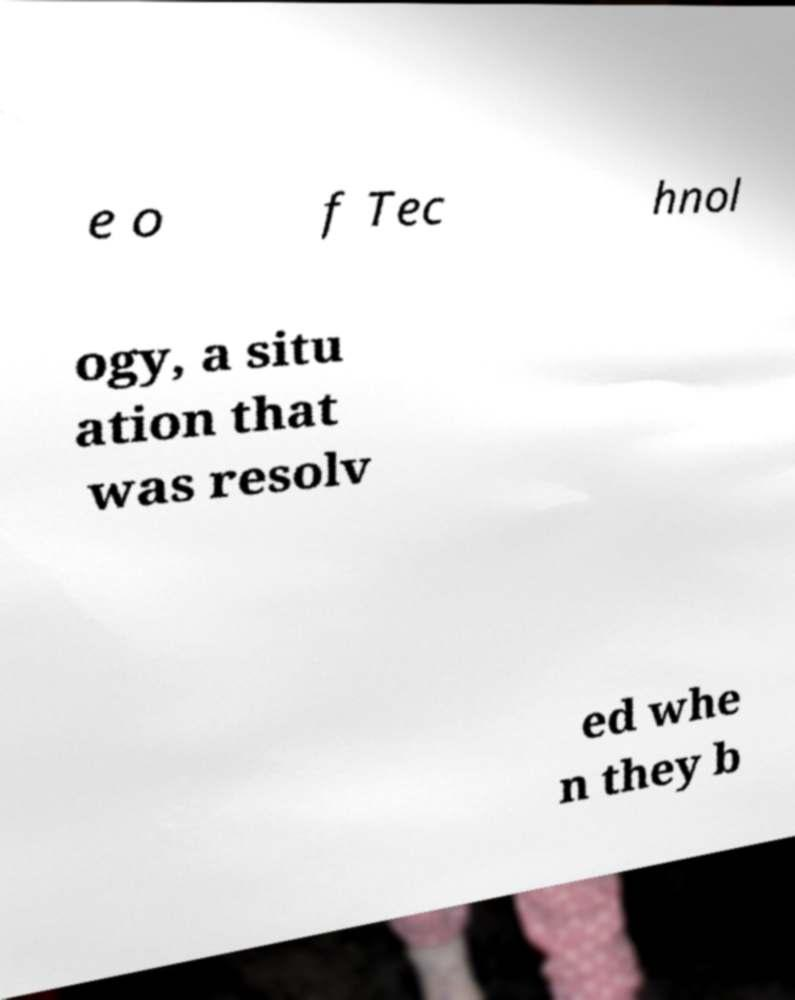Could you assist in decoding the text presented in this image and type it out clearly? e o f Tec hnol ogy, a situ ation that was resolv ed whe n they b 